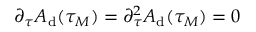<formula> <loc_0><loc_0><loc_500><loc_500>\partial _ { \tau } A _ { d } ( \tau _ { M } ) = \partial _ { \tau } ^ { 2 } A _ { d } ( \tau _ { M } ) = 0</formula> 